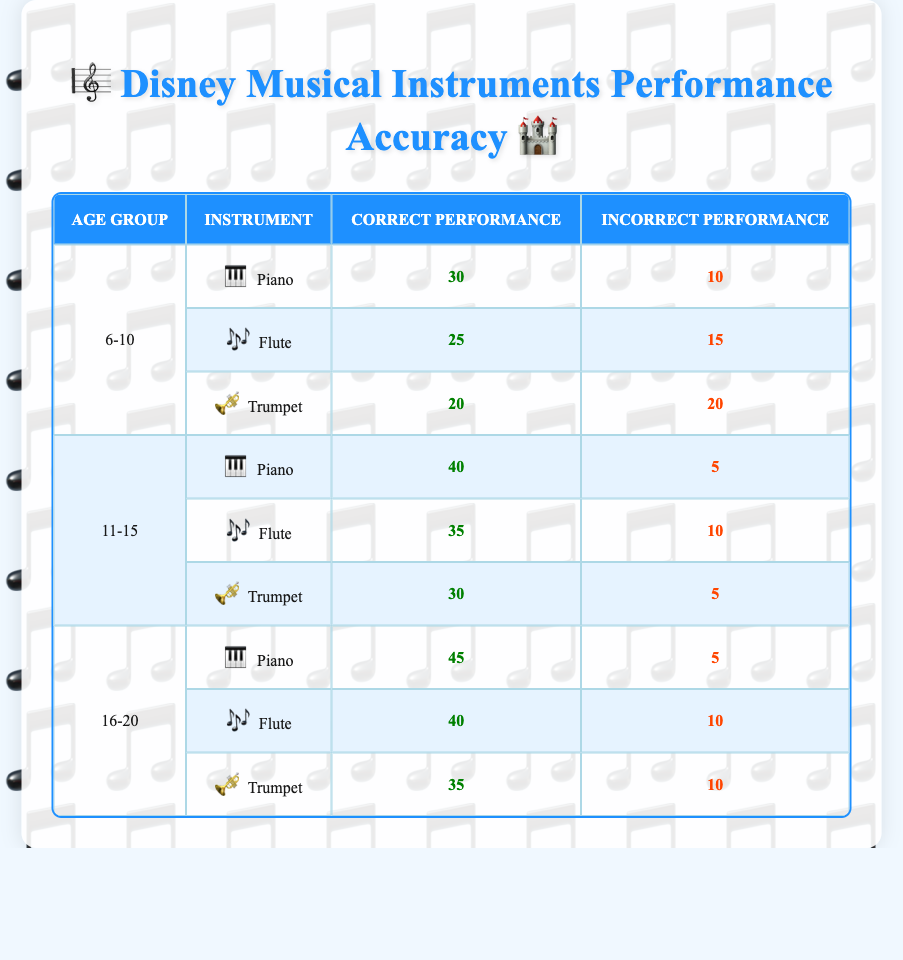What is the total correct performance for the Piano across all age groups? To find the total correct performance for the Piano, I will sum the correct performances in each age group: 30 (6-10) + 40 (11-15) + 45 (16-20) = 115.
Answer: 115 Which instrument has the highest incorrect performance in the age group 6-10? In the age group 6-10, the Trumpet has an incorrect performance of 20, which is higher than the Flute (15) and Piano (10).
Answer: Trumpet What is the average correct performance for the Flute across all age groups? The correct performances for the Flute are 25 (6-10), 35 (11-15), and 40 (16-20). I will calculate the average: sum = 25 + 35 + 40 = 100, and there are 3 data points, so the average is 100 / 3 = approximately 33.33.
Answer: 33.33 Is the incorrect performance for the Trumpet in the age group 11-15 lower than that in the age group 6-10? The incorrect performance for the Trumpet in the 11-15 age group is 5, while in the 6-10 age group it is 20. Since 5 is less than 20, the statement is true.
Answer: Yes Which instrument had the least correct performance in the 16-20 age group? In the 16-20 age group, the Trumpet has the least correct performance at 35 compared to the Piano (45) and Flute (40).
Answer: Trumpet What is the total incorrect performance for all instruments in the age group 11-15? For the age group 11-15, the incorrect performances are 5 (Piano) + 10 (Flute) + 5 (Trumpet), which totals 20.
Answer: 20 In which age group is the Piano's performance most accurate, based on the proportion of correct performance? The Piano's correct performance for each age group relative to total attempts: 6-10 has 30/(30+10) = 0.75, 11-15 has 40/(40+5) = 0.888, and 16-20 has 45/(45+5) = 0.9. The highest proportion is in the 16-20 age group.
Answer: 16-20 How many more correct performances does the Flute have in the age group 11-15 compared to age group 6-10? The Flute's correct performance in 11-15 is 35 and in 6-10 is 25. The difference is 35 - 25 = 10.
Answer: 10 